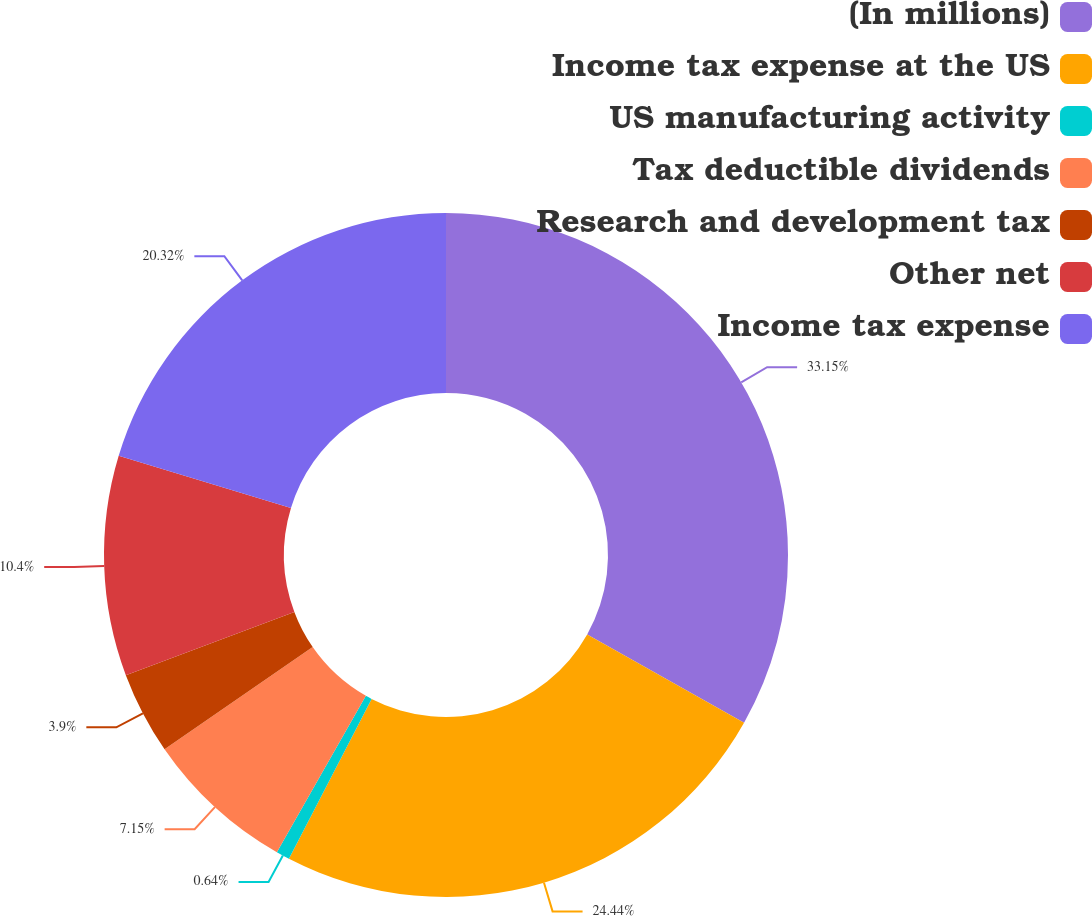<chart> <loc_0><loc_0><loc_500><loc_500><pie_chart><fcel>(In millions)<fcel>Income tax expense at the US<fcel>US manufacturing activity<fcel>Tax deductible dividends<fcel>Research and development tax<fcel>Other net<fcel>Income tax expense<nl><fcel>33.16%<fcel>24.44%<fcel>0.64%<fcel>7.15%<fcel>3.9%<fcel>10.4%<fcel>20.32%<nl></chart> 